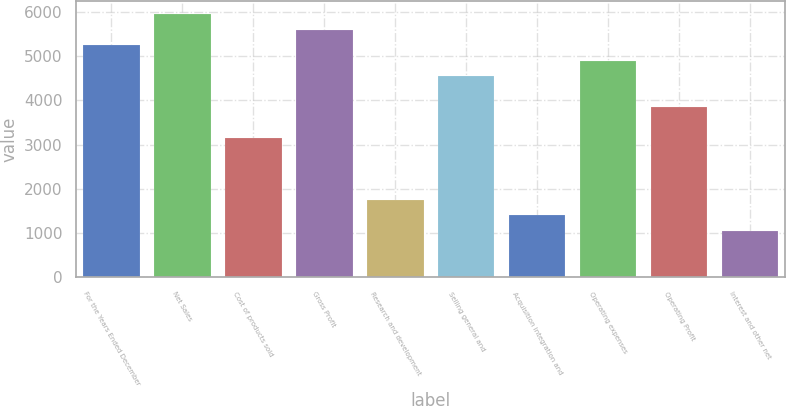Convert chart. <chart><loc_0><loc_0><loc_500><loc_500><bar_chart><fcel>For the Years Ended December<fcel>Net Sales<fcel>Cost of products sold<fcel>Gross Profit<fcel>Research and development<fcel>Selling general and<fcel>Acquisition integration and<fcel>Operating expenses<fcel>Operating Profit<fcel>Interest and other net<nl><fcel>5242.85<fcel>5941.83<fcel>3145.91<fcel>5592.34<fcel>1747.95<fcel>4543.87<fcel>1398.46<fcel>4893.36<fcel>3844.89<fcel>1048.97<nl></chart> 